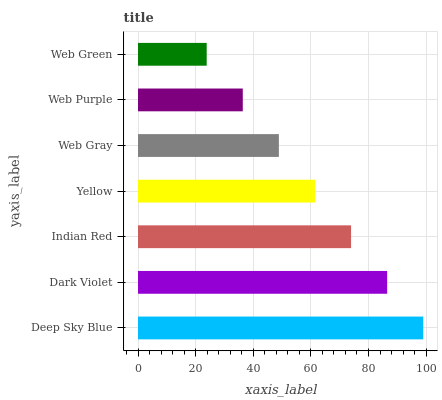Is Web Green the minimum?
Answer yes or no. Yes. Is Deep Sky Blue the maximum?
Answer yes or no. Yes. Is Dark Violet the minimum?
Answer yes or no. No. Is Dark Violet the maximum?
Answer yes or no. No. Is Deep Sky Blue greater than Dark Violet?
Answer yes or no. Yes. Is Dark Violet less than Deep Sky Blue?
Answer yes or no. Yes. Is Dark Violet greater than Deep Sky Blue?
Answer yes or no. No. Is Deep Sky Blue less than Dark Violet?
Answer yes or no. No. Is Yellow the high median?
Answer yes or no. Yes. Is Yellow the low median?
Answer yes or no. Yes. Is Dark Violet the high median?
Answer yes or no. No. Is Indian Red the low median?
Answer yes or no. No. 